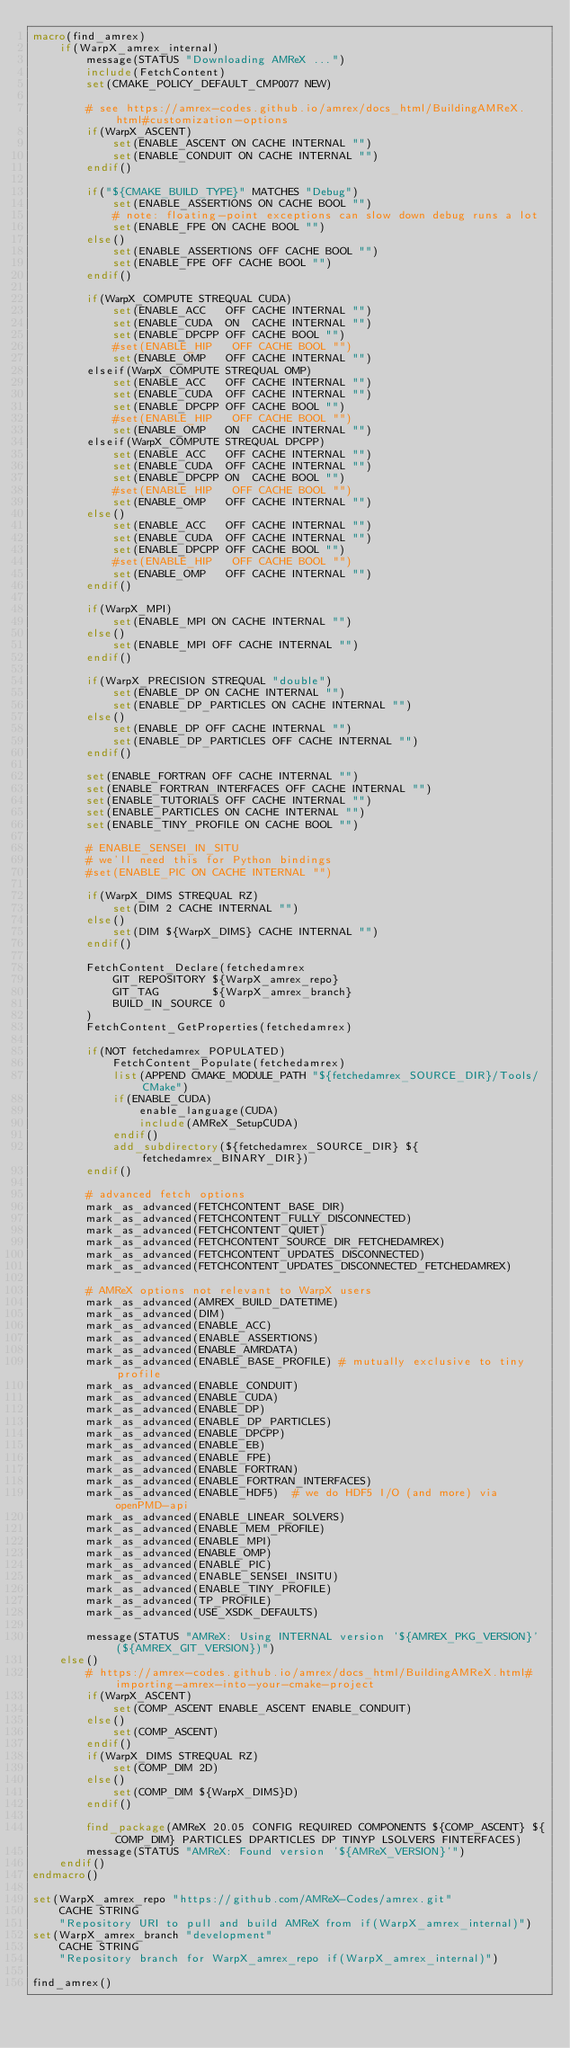Convert code to text. <code><loc_0><loc_0><loc_500><loc_500><_CMake_>macro(find_amrex)
    if(WarpX_amrex_internal)
        message(STATUS "Downloading AMReX ...")
        include(FetchContent)
        set(CMAKE_POLICY_DEFAULT_CMP0077 NEW)

        # see https://amrex-codes.github.io/amrex/docs_html/BuildingAMReX.html#customization-options
        if(WarpX_ASCENT)
            set(ENABLE_ASCENT ON CACHE INTERNAL "")
            set(ENABLE_CONDUIT ON CACHE INTERNAL "")
        endif()

        if("${CMAKE_BUILD_TYPE}" MATCHES "Debug")
            set(ENABLE_ASSERTIONS ON CACHE BOOL "")
            # note: floating-point exceptions can slow down debug runs a lot
            set(ENABLE_FPE ON CACHE BOOL "")
        else()
            set(ENABLE_ASSERTIONS OFF CACHE BOOL "")
            set(ENABLE_FPE OFF CACHE BOOL "")
        endif()

        if(WarpX_COMPUTE STREQUAL CUDA)
            set(ENABLE_ACC   OFF CACHE INTERNAL "")
            set(ENABLE_CUDA  ON  CACHE INTERNAL "")
            set(ENABLE_DPCPP OFF CACHE BOOL "")
            #set(ENABLE_HIP   OFF CACHE BOOL "")
            set(ENABLE_OMP   OFF CACHE INTERNAL "")
        elseif(WarpX_COMPUTE STREQUAL OMP)
            set(ENABLE_ACC   OFF CACHE INTERNAL "")
            set(ENABLE_CUDA  OFF CACHE INTERNAL "")
            set(ENABLE_DPCPP OFF CACHE BOOL "")
            #set(ENABLE_HIP   OFF CACHE BOOL "")
            set(ENABLE_OMP   ON  CACHE INTERNAL "")
        elseif(WarpX_COMPUTE STREQUAL DPCPP)
            set(ENABLE_ACC   OFF CACHE INTERNAL "")
            set(ENABLE_CUDA  OFF CACHE INTERNAL "")
            set(ENABLE_DPCPP ON  CACHE BOOL "")
            #set(ENABLE_HIP   OFF CACHE BOOL "")
            set(ENABLE_OMP   OFF CACHE INTERNAL "")
        else()
            set(ENABLE_ACC   OFF CACHE INTERNAL "")
            set(ENABLE_CUDA  OFF CACHE INTERNAL "")
            set(ENABLE_DPCPP OFF CACHE BOOL "")
            #set(ENABLE_HIP   OFF CACHE BOOL "")
            set(ENABLE_OMP   OFF CACHE INTERNAL "")
        endif()

        if(WarpX_MPI)
            set(ENABLE_MPI ON CACHE INTERNAL "")
        else()
            set(ENABLE_MPI OFF CACHE INTERNAL "")
        endif()

        if(WarpX_PRECISION STREQUAL "double")
            set(ENABLE_DP ON CACHE INTERNAL "")
            set(ENABLE_DP_PARTICLES ON CACHE INTERNAL "")
        else()
            set(ENABLE_DP OFF CACHE INTERNAL "")
            set(ENABLE_DP_PARTICLES OFF CACHE INTERNAL "")
        endif()

        set(ENABLE_FORTRAN OFF CACHE INTERNAL "")
        set(ENABLE_FORTRAN_INTERFACES OFF CACHE INTERNAL "")
        set(ENABLE_TUTORIALS OFF CACHE INTERNAL "")
        set(ENABLE_PARTICLES ON CACHE INTERNAL "")
        set(ENABLE_TINY_PROFILE ON CACHE BOOL "")

        # ENABLE_SENSEI_IN_SITU
        # we'll need this for Python bindings
        #set(ENABLE_PIC ON CACHE INTERNAL "")

        if(WarpX_DIMS STREQUAL RZ)
            set(DIM 2 CACHE INTERNAL "")
        else()
            set(DIM ${WarpX_DIMS} CACHE INTERNAL "")
        endif()

        FetchContent_Declare(fetchedamrex
            GIT_REPOSITORY ${WarpX_amrex_repo}
            GIT_TAG        ${WarpX_amrex_branch}
            BUILD_IN_SOURCE 0
        )
        FetchContent_GetProperties(fetchedamrex)

        if(NOT fetchedamrex_POPULATED)
            FetchContent_Populate(fetchedamrex)
            list(APPEND CMAKE_MODULE_PATH "${fetchedamrex_SOURCE_DIR}/Tools/CMake")
            if(ENABLE_CUDA)
                enable_language(CUDA)
                include(AMReX_SetupCUDA)
            endif()
            add_subdirectory(${fetchedamrex_SOURCE_DIR} ${fetchedamrex_BINARY_DIR})
        endif()

        # advanced fetch options
        mark_as_advanced(FETCHCONTENT_BASE_DIR)
        mark_as_advanced(FETCHCONTENT_FULLY_DISCONNECTED)
        mark_as_advanced(FETCHCONTENT_QUIET)
        mark_as_advanced(FETCHCONTENT_SOURCE_DIR_FETCHEDAMREX)
        mark_as_advanced(FETCHCONTENT_UPDATES_DISCONNECTED)
        mark_as_advanced(FETCHCONTENT_UPDATES_DISCONNECTED_FETCHEDAMREX)

        # AMReX options not relevant to WarpX users
        mark_as_advanced(AMREX_BUILD_DATETIME)
        mark_as_advanced(DIM)
        mark_as_advanced(ENABLE_ACC)
        mark_as_advanced(ENABLE_ASSERTIONS)
        mark_as_advanced(ENABLE_AMRDATA)
        mark_as_advanced(ENABLE_BASE_PROFILE) # mutually exclusive to tiny profile
        mark_as_advanced(ENABLE_CONDUIT)
        mark_as_advanced(ENABLE_CUDA)
        mark_as_advanced(ENABLE_DP)
        mark_as_advanced(ENABLE_DP_PARTICLES)
        mark_as_advanced(ENABLE_DPCPP)
        mark_as_advanced(ENABLE_EB)
        mark_as_advanced(ENABLE_FPE)
        mark_as_advanced(ENABLE_FORTRAN)
        mark_as_advanced(ENABLE_FORTRAN_INTERFACES)
        mark_as_advanced(ENABLE_HDF5)  # we do HDF5 I/O (and more) via openPMD-api
        mark_as_advanced(ENABLE_LINEAR_SOLVERS)
        mark_as_advanced(ENABLE_MEM_PROFILE)
        mark_as_advanced(ENABLE_MPI)
        mark_as_advanced(ENABLE_OMP)
        mark_as_advanced(ENABLE_PIC)
        mark_as_advanced(ENABLE_SENSEI_INSITU)
        mark_as_advanced(ENABLE_TINY_PROFILE)
        mark_as_advanced(TP_PROFILE)
        mark_as_advanced(USE_XSDK_DEFAULTS)

        message(STATUS "AMReX: Using INTERNAL version '${AMREX_PKG_VERSION}' (${AMREX_GIT_VERSION})")
    else()
        # https://amrex-codes.github.io/amrex/docs_html/BuildingAMReX.html#importing-amrex-into-your-cmake-project
        if(WarpX_ASCENT)
            set(COMP_ASCENT ENABLE_ASCENT ENABLE_CONDUIT)
        else()
            set(COMP_ASCENT)
        endif()
        if(WarpX_DIMS STREQUAL RZ)
            set(COMP_DIM 2D)
        else()
            set(COMP_DIM ${WarpX_DIMS}D)
        endif()

        find_package(AMReX 20.05 CONFIG REQUIRED COMPONENTS ${COMP_ASCENT} ${COMP_DIM} PARTICLES DPARTICLES DP TINYP LSOLVERS FINTERFACES)
        message(STATUS "AMReX: Found version '${AMReX_VERSION}'")
    endif()
endmacro()

set(WarpX_amrex_repo "https://github.com/AMReX-Codes/amrex.git"
    CACHE STRING
    "Repository URI to pull and build AMReX from if(WarpX_amrex_internal)")
set(WarpX_amrex_branch "development"
    CACHE STRING
    "Repository branch for WarpX_amrex_repo if(WarpX_amrex_internal)")

find_amrex()
</code> 